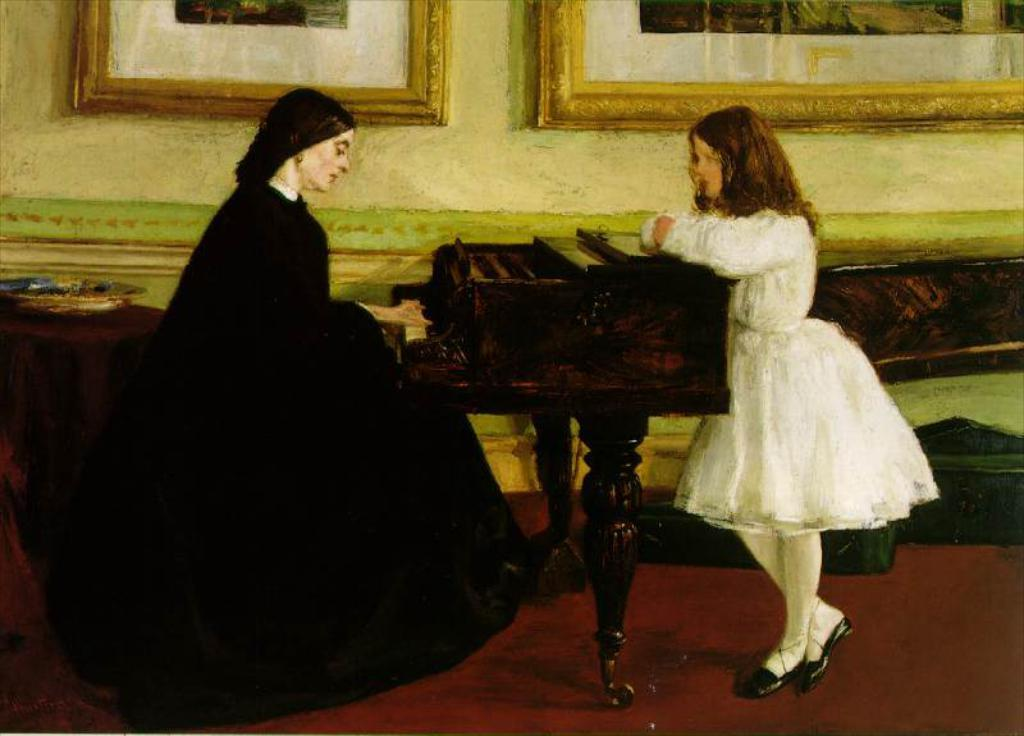Who is the main subject in the image? There is a woman in the image. What is the woman doing in the image? The woman is sitting on a chair and playing a piano. Are there any other people in the image? Yes, there is another girl in the image. What is the girl doing in the image? The girl is standing in front of the piano. What type of breakfast is being served in the image? There is no breakfast present in the image; it features a woman playing a piano and a girl standing in front of it. 